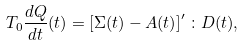Convert formula to latex. <formula><loc_0><loc_0><loc_500><loc_500>T _ { 0 } \frac { d Q } { d t } ( t ) = \left [ { \Sigma } ( t ) - { A } ( t ) \right ] ^ { \prime } \colon { D } ( t ) ,</formula> 